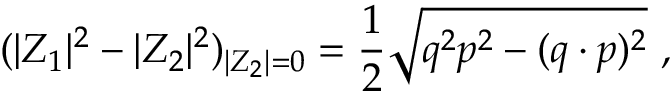Convert formula to latex. <formula><loc_0><loc_0><loc_500><loc_500>( | Z _ { 1 } | ^ { 2 } - | Z _ { 2 } | ^ { 2 } ) _ { | Z _ { 2 } | = 0 } = { \frac { 1 } { 2 } } \sqrt { q ^ { 2 } p ^ { 2 } - ( q \cdot p ) ^ { 2 } } \ ,</formula> 